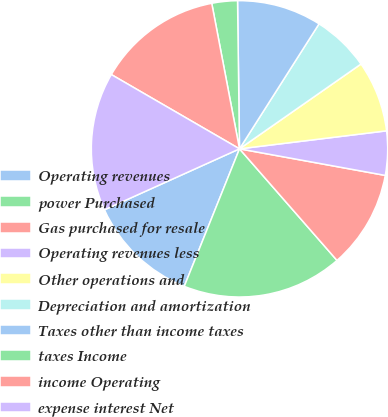Convert chart. <chart><loc_0><loc_0><loc_500><loc_500><pie_chart><fcel>Operating revenues<fcel>power Purchased<fcel>Gas purchased for resale<fcel>Operating revenues less<fcel>Other operations and<fcel>Depreciation and amortization<fcel>Taxes other than income taxes<fcel>taxes Income<fcel>income Operating<fcel>expense interest Net<nl><fcel>12.17%<fcel>17.51%<fcel>10.7%<fcel>4.81%<fcel>7.76%<fcel>6.28%<fcel>9.23%<fcel>2.79%<fcel>13.64%<fcel>15.11%<nl></chart> 